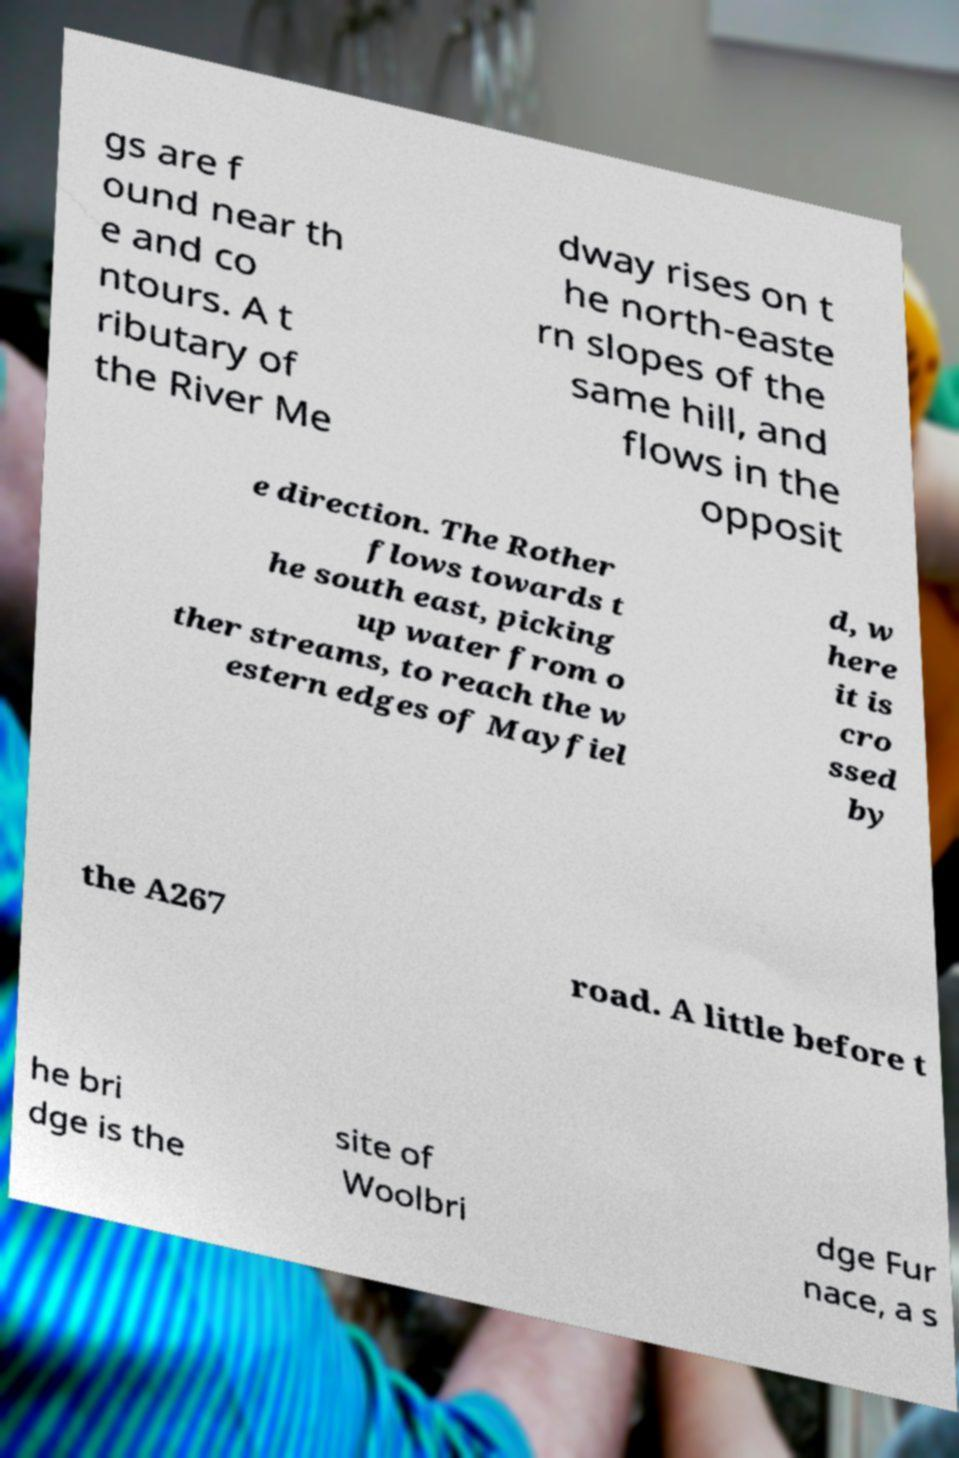For documentation purposes, I need the text within this image transcribed. Could you provide that? gs are f ound near th e and co ntours. A t ributary of the River Me dway rises on t he north-easte rn slopes of the same hill, and flows in the opposit e direction. The Rother flows towards t he south east, picking up water from o ther streams, to reach the w estern edges of Mayfiel d, w here it is cro ssed by the A267 road. A little before t he bri dge is the site of Woolbri dge Fur nace, a s 